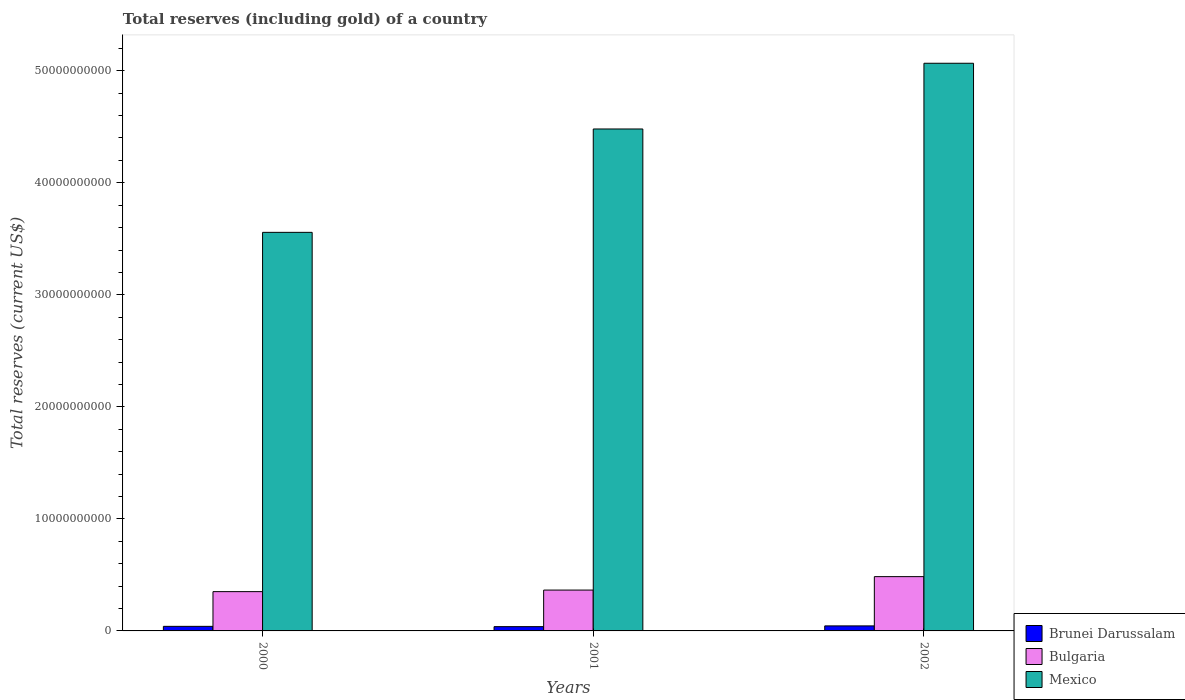How many different coloured bars are there?
Your answer should be compact. 3. How many groups of bars are there?
Offer a very short reply. 3. What is the label of the 1st group of bars from the left?
Provide a succinct answer. 2000. In how many cases, is the number of bars for a given year not equal to the number of legend labels?
Provide a short and direct response. 0. What is the total reserves (including gold) in Mexico in 2002?
Ensure brevity in your answer.  5.07e+1. Across all years, what is the maximum total reserves (including gold) in Brunei Darussalam?
Make the answer very short. 4.49e+08. Across all years, what is the minimum total reserves (including gold) in Brunei Darussalam?
Make the answer very short. 3.82e+08. In which year was the total reserves (including gold) in Mexico maximum?
Your response must be concise. 2002. What is the total total reserves (including gold) in Bulgaria in the graph?
Give a very brief answer. 1.20e+1. What is the difference between the total reserves (including gold) in Mexico in 2000 and that in 2002?
Provide a short and direct response. -1.51e+1. What is the difference between the total reserves (including gold) in Bulgaria in 2000 and the total reserves (including gold) in Brunei Darussalam in 2001?
Ensure brevity in your answer.  3.13e+09. What is the average total reserves (including gold) in Bulgaria per year?
Offer a very short reply. 4.00e+09. In the year 2000, what is the difference between the total reserves (including gold) in Bulgaria and total reserves (including gold) in Brunei Darussalam?
Provide a succinct answer. 3.10e+09. In how many years, is the total reserves (including gold) in Bulgaria greater than 40000000000 US$?
Ensure brevity in your answer.  0. What is the ratio of the total reserves (including gold) in Brunei Darussalam in 2001 to that in 2002?
Provide a succinct answer. 0.85. What is the difference between the highest and the second highest total reserves (including gold) in Mexico?
Ensure brevity in your answer.  5.87e+09. What is the difference between the highest and the lowest total reserves (including gold) in Brunei Darussalam?
Your answer should be compact. 6.72e+07. What does the 3rd bar from the left in 2002 represents?
Keep it short and to the point. Mexico. What does the 2nd bar from the right in 2002 represents?
Offer a very short reply. Bulgaria. Is it the case that in every year, the sum of the total reserves (including gold) in Bulgaria and total reserves (including gold) in Brunei Darussalam is greater than the total reserves (including gold) in Mexico?
Keep it short and to the point. No. Are all the bars in the graph horizontal?
Your answer should be compact. No. Are the values on the major ticks of Y-axis written in scientific E-notation?
Keep it short and to the point. No. Does the graph contain grids?
Your answer should be compact. No. Where does the legend appear in the graph?
Offer a terse response. Bottom right. How many legend labels are there?
Provide a short and direct response. 3. What is the title of the graph?
Provide a short and direct response. Total reserves (including gold) of a country. What is the label or title of the X-axis?
Keep it short and to the point. Years. What is the label or title of the Y-axis?
Provide a short and direct response. Total reserves (current US$). What is the Total reserves (current US$) of Brunei Darussalam in 2000?
Make the answer very short. 4.08e+08. What is the Total reserves (current US$) of Bulgaria in 2000?
Make the answer very short. 3.51e+09. What is the Total reserves (current US$) of Mexico in 2000?
Keep it short and to the point. 3.56e+1. What is the Total reserves (current US$) of Brunei Darussalam in 2001?
Keep it short and to the point. 3.82e+08. What is the Total reserves (current US$) of Bulgaria in 2001?
Offer a very short reply. 3.65e+09. What is the Total reserves (current US$) in Mexico in 2001?
Offer a terse response. 4.48e+1. What is the Total reserves (current US$) of Brunei Darussalam in 2002?
Make the answer very short. 4.49e+08. What is the Total reserves (current US$) in Bulgaria in 2002?
Ensure brevity in your answer.  4.85e+09. What is the Total reserves (current US$) of Mexico in 2002?
Offer a very short reply. 5.07e+1. Across all years, what is the maximum Total reserves (current US$) in Brunei Darussalam?
Make the answer very short. 4.49e+08. Across all years, what is the maximum Total reserves (current US$) in Bulgaria?
Make the answer very short. 4.85e+09. Across all years, what is the maximum Total reserves (current US$) of Mexico?
Ensure brevity in your answer.  5.07e+1. Across all years, what is the minimum Total reserves (current US$) of Brunei Darussalam?
Make the answer very short. 3.82e+08. Across all years, what is the minimum Total reserves (current US$) in Bulgaria?
Offer a very short reply. 3.51e+09. Across all years, what is the minimum Total reserves (current US$) of Mexico?
Your answer should be compact. 3.56e+1. What is the total Total reserves (current US$) in Brunei Darussalam in the graph?
Offer a very short reply. 1.24e+09. What is the total Total reserves (current US$) of Bulgaria in the graph?
Give a very brief answer. 1.20e+1. What is the total Total reserves (current US$) of Mexico in the graph?
Ensure brevity in your answer.  1.31e+11. What is the difference between the Total reserves (current US$) of Brunei Darussalam in 2000 and that in 2001?
Your response must be concise. 2.65e+07. What is the difference between the Total reserves (current US$) of Bulgaria in 2000 and that in 2001?
Provide a short and direct response. -1.39e+08. What is the difference between the Total reserves (current US$) of Mexico in 2000 and that in 2001?
Your answer should be very brief. -9.23e+09. What is the difference between the Total reserves (current US$) in Brunei Darussalam in 2000 and that in 2002?
Provide a short and direct response. -4.07e+07. What is the difference between the Total reserves (current US$) of Bulgaria in 2000 and that in 2002?
Provide a succinct answer. -1.34e+09. What is the difference between the Total reserves (current US$) in Mexico in 2000 and that in 2002?
Give a very brief answer. -1.51e+1. What is the difference between the Total reserves (current US$) in Brunei Darussalam in 2001 and that in 2002?
Make the answer very short. -6.72e+07. What is the difference between the Total reserves (current US$) of Bulgaria in 2001 and that in 2002?
Ensure brevity in your answer.  -1.20e+09. What is the difference between the Total reserves (current US$) in Mexico in 2001 and that in 2002?
Make the answer very short. -5.87e+09. What is the difference between the Total reserves (current US$) in Brunei Darussalam in 2000 and the Total reserves (current US$) in Bulgaria in 2001?
Ensure brevity in your answer.  -3.24e+09. What is the difference between the Total reserves (current US$) in Brunei Darussalam in 2000 and the Total reserves (current US$) in Mexico in 2001?
Provide a short and direct response. -4.44e+1. What is the difference between the Total reserves (current US$) of Bulgaria in 2000 and the Total reserves (current US$) of Mexico in 2001?
Provide a succinct answer. -4.13e+1. What is the difference between the Total reserves (current US$) in Brunei Darussalam in 2000 and the Total reserves (current US$) in Bulgaria in 2002?
Keep it short and to the point. -4.44e+09. What is the difference between the Total reserves (current US$) of Brunei Darussalam in 2000 and the Total reserves (current US$) of Mexico in 2002?
Provide a short and direct response. -5.03e+1. What is the difference between the Total reserves (current US$) of Bulgaria in 2000 and the Total reserves (current US$) of Mexico in 2002?
Give a very brief answer. -4.72e+1. What is the difference between the Total reserves (current US$) of Brunei Darussalam in 2001 and the Total reserves (current US$) of Bulgaria in 2002?
Keep it short and to the point. -4.46e+09. What is the difference between the Total reserves (current US$) in Brunei Darussalam in 2001 and the Total reserves (current US$) in Mexico in 2002?
Your response must be concise. -5.03e+1. What is the difference between the Total reserves (current US$) of Bulgaria in 2001 and the Total reserves (current US$) of Mexico in 2002?
Offer a very short reply. -4.70e+1. What is the average Total reserves (current US$) of Brunei Darussalam per year?
Give a very brief answer. 4.13e+08. What is the average Total reserves (current US$) in Bulgaria per year?
Make the answer very short. 4.00e+09. What is the average Total reserves (current US$) in Mexico per year?
Your answer should be compact. 4.37e+1. In the year 2000, what is the difference between the Total reserves (current US$) of Brunei Darussalam and Total reserves (current US$) of Bulgaria?
Your answer should be compact. -3.10e+09. In the year 2000, what is the difference between the Total reserves (current US$) in Brunei Darussalam and Total reserves (current US$) in Mexico?
Provide a short and direct response. -3.52e+1. In the year 2000, what is the difference between the Total reserves (current US$) in Bulgaria and Total reserves (current US$) in Mexico?
Provide a short and direct response. -3.21e+1. In the year 2001, what is the difference between the Total reserves (current US$) in Brunei Darussalam and Total reserves (current US$) in Bulgaria?
Offer a terse response. -3.26e+09. In the year 2001, what is the difference between the Total reserves (current US$) of Brunei Darussalam and Total reserves (current US$) of Mexico?
Your answer should be very brief. -4.44e+1. In the year 2001, what is the difference between the Total reserves (current US$) of Bulgaria and Total reserves (current US$) of Mexico?
Provide a short and direct response. -4.12e+1. In the year 2002, what is the difference between the Total reserves (current US$) of Brunei Darussalam and Total reserves (current US$) of Bulgaria?
Make the answer very short. -4.40e+09. In the year 2002, what is the difference between the Total reserves (current US$) in Brunei Darussalam and Total reserves (current US$) in Mexico?
Ensure brevity in your answer.  -5.02e+1. In the year 2002, what is the difference between the Total reserves (current US$) in Bulgaria and Total reserves (current US$) in Mexico?
Offer a very short reply. -4.58e+1. What is the ratio of the Total reserves (current US$) of Brunei Darussalam in 2000 to that in 2001?
Your answer should be compact. 1.07. What is the ratio of the Total reserves (current US$) of Bulgaria in 2000 to that in 2001?
Your response must be concise. 0.96. What is the ratio of the Total reserves (current US$) in Mexico in 2000 to that in 2001?
Provide a succinct answer. 0.79. What is the ratio of the Total reserves (current US$) in Brunei Darussalam in 2000 to that in 2002?
Your answer should be very brief. 0.91. What is the ratio of the Total reserves (current US$) in Bulgaria in 2000 to that in 2002?
Provide a succinct answer. 0.72. What is the ratio of the Total reserves (current US$) of Mexico in 2000 to that in 2002?
Your answer should be compact. 0.7. What is the ratio of the Total reserves (current US$) of Brunei Darussalam in 2001 to that in 2002?
Provide a short and direct response. 0.85. What is the ratio of the Total reserves (current US$) in Bulgaria in 2001 to that in 2002?
Offer a very short reply. 0.75. What is the ratio of the Total reserves (current US$) in Mexico in 2001 to that in 2002?
Make the answer very short. 0.88. What is the difference between the highest and the second highest Total reserves (current US$) of Brunei Darussalam?
Make the answer very short. 4.07e+07. What is the difference between the highest and the second highest Total reserves (current US$) of Bulgaria?
Your answer should be compact. 1.20e+09. What is the difference between the highest and the second highest Total reserves (current US$) of Mexico?
Your response must be concise. 5.87e+09. What is the difference between the highest and the lowest Total reserves (current US$) of Brunei Darussalam?
Ensure brevity in your answer.  6.72e+07. What is the difference between the highest and the lowest Total reserves (current US$) in Bulgaria?
Your answer should be compact. 1.34e+09. What is the difference between the highest and the lowest Total reserves (current US$) of Mexico?
Give a very brief answer. 1.51e+1. 